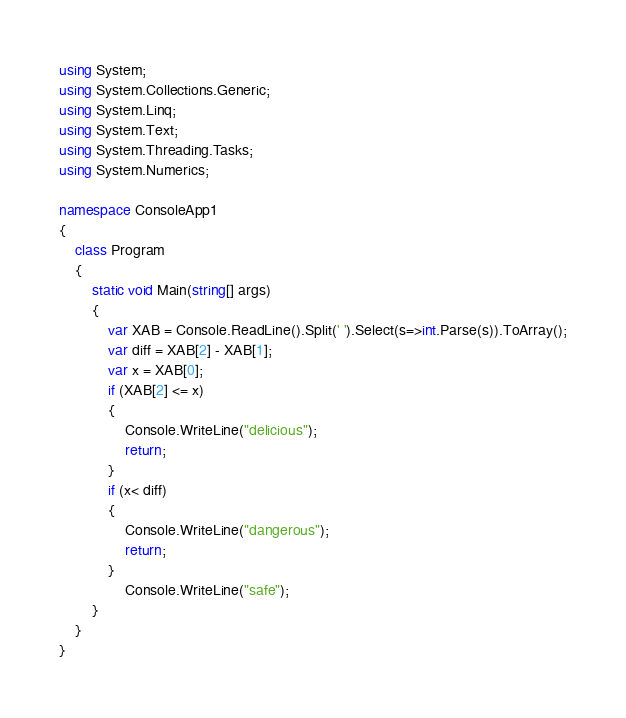Convert code to text. <code><loc_0><loc_0><loc_500><loc_500><_C#_>using System;
using System.Collections.Generic;
using System.Linq;
using System.Text;
using System.Threading.Tasks;
using System.Numerics;

namespace ConsoleApp1
{
    class Program
    {
        static void Main(string[] args)
        {
            var XAB = Console.ReadLine().Split(' ').Select(s=>int.Parse(s)).ToArray();
            var diff = XAB[2] - XAB[1];
            var x = XAB[0];
            if (XAB[2] <= x)
            {
                Console.WriteLine("delicious");
                return;
            }
            if (x< diff)
            {
                Console.WriteLine("dangerous");
                return;
            }
                Console.WriteLine("safe");
        }
    }
}
</code> 